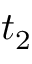<formula> <loc_0><loc_0><loc_500><loc_500>t _ { 2 }</formula> 